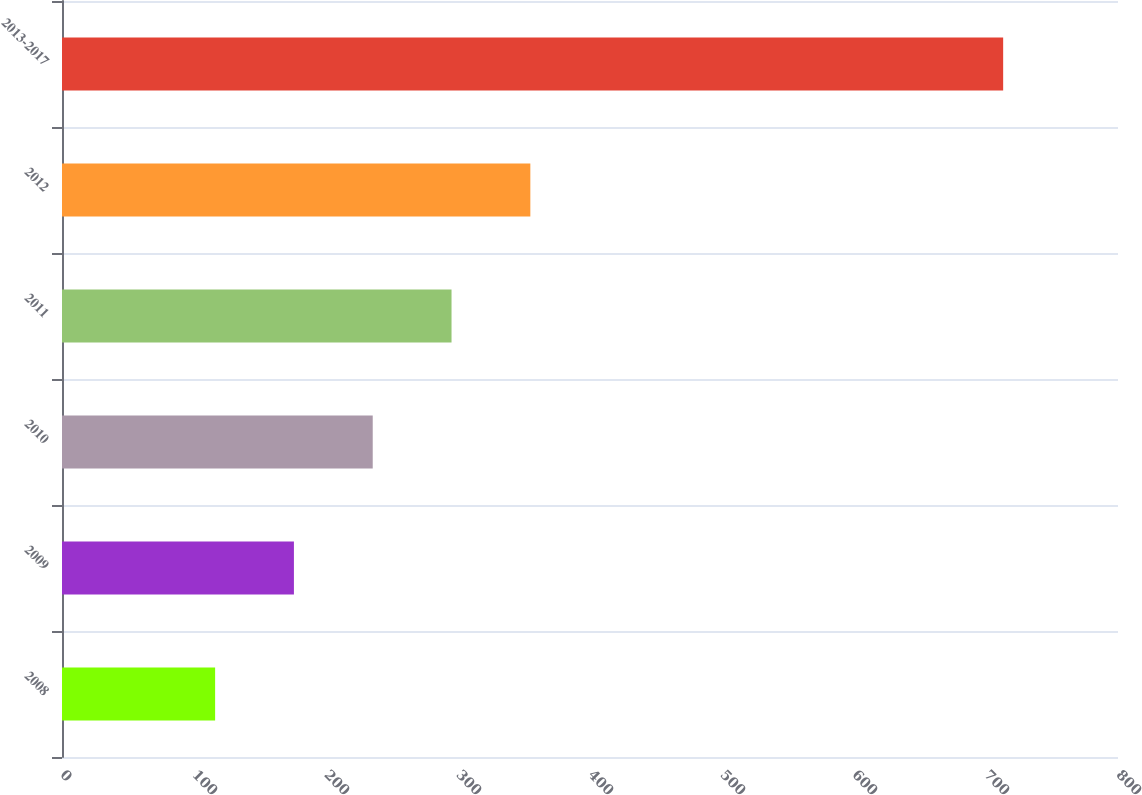Convert chart to OTSL. <chart><loc_0><loc_0><loc_500><loc_500><bar_chart><fcel>2008<fcel>2009<fcel>2010<fcel>2011<fcel>2012<fcel>2013-2017<nl><fcel>116<fcel>175.7<fcel>235.4<fcel>295.1<fcel>354.8<fcel>713<nl></chart> 